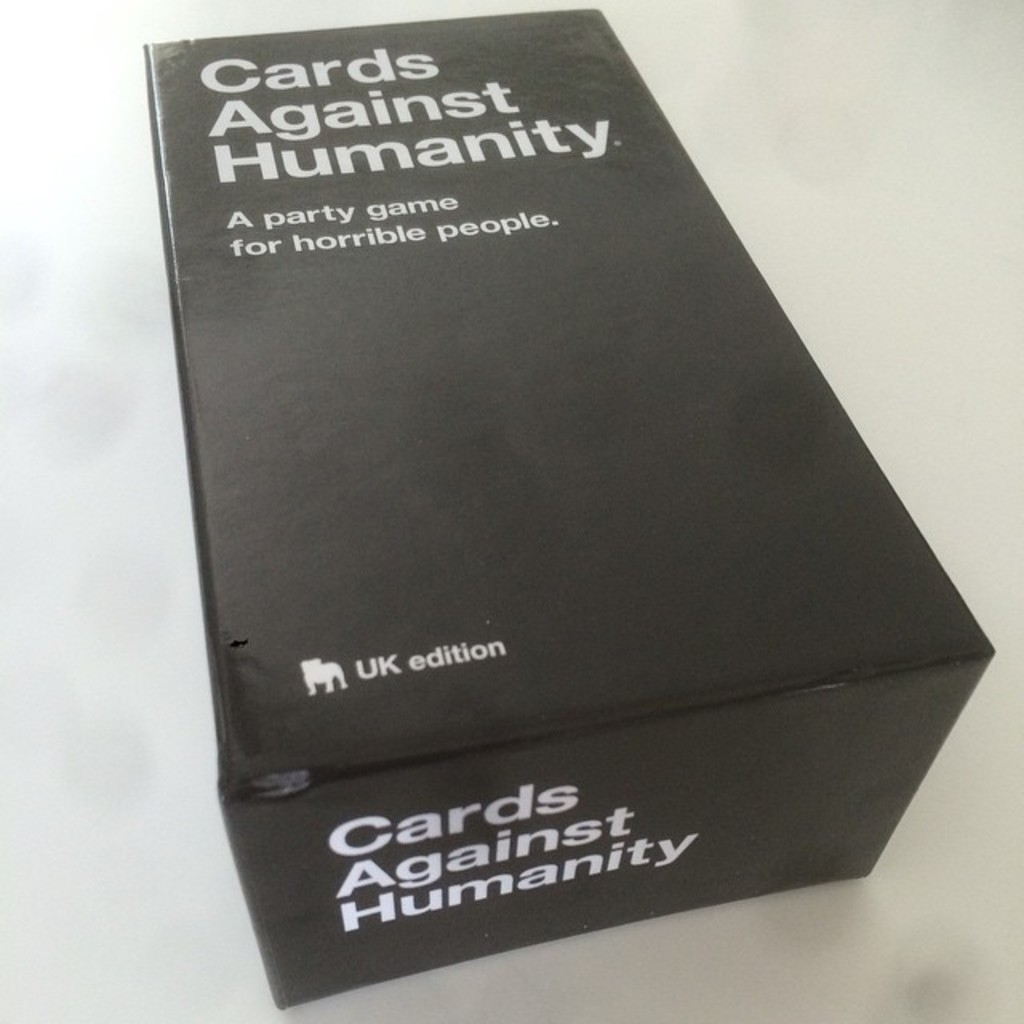What does the 'UK edition' imply about the contents of this game? The 'UK edition' tag on this version of 'Cards Against Humanity' suggests that the game includes cards that are specifically tailored to British culture and humor. These might contain local slang, references to British celebrities, political issues, or historical events, which are designed to resonate more with a UK audience and enhance the relevance and enjoyment of the game for players in that region. 